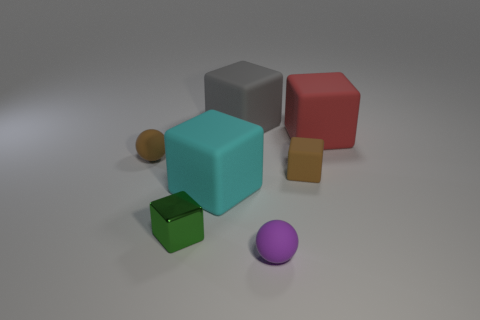Subtract 2 cubes. How many cubes are left? 3 Subtract all brown rubber blocks. How many blocks are left? 4 Subtract all brown blocks. How many blocks are left? 4 Add 3 tiny brown objects. How many objects exist? 10 Subtract all purple cubes. Subtract all gray balls. How many cubes are left? 5 Subtract all blocks. How many objects are left? 2 Subtract all cyan rubber cubes. Subtract all big cyan matte objects. How many objects are left? 5 Add 2 tiny spheres. How many tiny spheres are left? 4 Add 4 cyan objects. How many cyan objects exist? 5 Subtract 1 brown cubes. How many objects are left? 6 